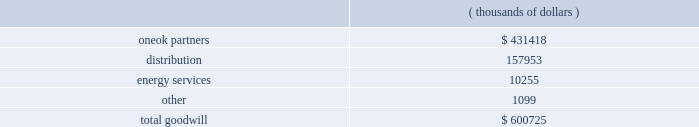Impairment of long-lived assets , goodwill and intangible assets - we assess our long-lived assets for impairment based on statement 144 , 201caccounting for the impairment or disposal of long-lived assets . 201d a long-lived asset is tested for impairment whenever events or changes in circumstances indicate that its carrying amount may exceed its fair value .
Fair values are based on the sum of the undiscounted future cash flows expected to result from the use and eventual disposition of the assets .
We assess our goodwill and intangible assets for impairment at least annually based on statement 142 , 201cgoodwill and other intangible assets . 201d there were no impairment charges resulting from the july 1 , 2007 , impairment tests and no events indicating an impairment have occurred subsequent to that date .
An initial assessment is made by comparing the fair value of the operations with goodwill , as determined in accordance with statement 142 , to the book value of each reporting unit .
If the fair value is less than the book value , an impairment is indicated , and we must perform a second test to measure the amount of the impairment .
In the second test , we calculate the implied fair value of the goodwill by deducting the fair value of all tangible and intangible net assets of the operations with goodwill from the fair value determined in step one of the assessment .
If the carrying value of the goodwill exceeds this calculated implied fair value of the goodwill , we will record an impairment charge .
At december 31 , 2007 , we had $ 600.7 million of goodwill recorded on our consolidated balance sheet as shown below. .
( thousands of dollars ) intangible assets with a finite useful life are amortized over their estimated useful life , while intangible assets with an indefinite useful life are not amortized .
All intangible assets are subject to impairment testing .
Our oneok partners segment had $ 443.0 million of intangible assets recorded on our consolidated balance sheet as of december 31 , 2007 , of which $ 287.5 million is being amortized over an aggregate weighted-average period of 40 years , while the remaining balance has an indefinite life .
During 2006 , we recorded a goodwill and asset impairment related to oneok partners 2019 black mesa pipeline of $ 8.4 million and $ 3.6 million , respectively , which were recorded as depreciation and amortization .
The reduction to our net income , net of minority interests and income taxes , was $ 3.0 million .
In the third quarter of 2005 , we made the decision to sell our spring creek power plant , located in oklahoma , and exit the power generation business .
In october 2005 , we concluded that our spring creek power plant had been impaired and recorded an impairment expense of $ 52.2 million .
This conclusion was based on our statement 144 impairment analysis of the results of operations for this plant through september 30 , 2005 , and also the net sales proceeds from the anticipated sale of the plant .
The sale was completed on october 31 , 2006 .
This component of our business is accounted for as discontinued operations in accordance with statement 144 .
See 201cdiscontinued operations 201d on page 46 for additional information .
Our total unamortized excess cost over underlying fair value of net assets accounted for under the equity method was $ 185.6 million as of december 31 , 2007 and 2006 .
Based on statement 142 , this amount , referred to as equity method goodwill , should continue to be recognized in accordance with apb opinion no .
18 , 201cthe equity method of accounting for investments in common stock . 201d accordingly , we included this amount in investment in unconsolidated affiliates on our accompanying consolidated balance sheets .
Pension and postretirement employee benefits - we have defined benefit retirement plans covering certain full-time employees .
We sponsor welfare plans that provide postretirement medical and life insurance benefits to certain employees who retire with at least five years of service .
Our actuarial consultant calculates the expense and liability related to these plans and uses statistical and other factors that attempt to anticipate future events .
These factors include assumptions about the discount rate , expected return on plan assets , rate of future compensation increases , age and employment periods .
In determining the projected benefit obligations and costs , assumptions can change from period to period and result in material changes in the costs and liabilities we recognize .
See note j of the notes to consolidated financial statements in this annual report on form 10-k for additional information. .
What percentage of total goodwill does oneok partners represent at december 31 , 2007? 
Computations: (431418 / 600725)
Answer: 0.71816. Impairment of long-lived assets , goodwill and intangible assets - we assess our long-lived assets for impairment based on statement 144 , 201caccounting for the impairment or disposal of long-lived assets . 201d a long-lived asset is tested for impairment whenever events or changes in circumstances indicate that its carrying amount may exceed its fair value .
Fair values are based on the sum of the undiscounted future cash flows expected to result from the use and eventual disposition of the assets .
We assess our goodwill and intangible assets for impairment at least annually based on statement 142 , 201cgoodwill and other intangible assets . 201d there were no impairment charges resulting from the july 1 , 2007 , impairment tests and no events indicating an impairment have occurred subsequent to that date .
An initial assessment is made by comparing the fair value of the operations with goodwill , as determined in accordance with statement 142 , to the book value of each reporting unit .
If the fair value is less than the book value , an impairment is indicated , and we must perform a second test to measure the amount of the impairment .
In the second test , we calculate the implied fair value of the goodwill by deducting the fair value of all tangible and intangible net assets of the operations with goodwill from the fair value determined in step one of the assessment .
If the carrying value of the goodwill exceeds this calculated implied fair value of the goodwill , we will record an impairment charge .
At december 31 , 2007 , we had $ 600.7 million of goodwill recorded on our consolidated balance sheet as shown below. .
( thousands of dollars ) intangible assets with a finite useful life are amortized over their estimated useful life , while intangible assets with an indefinite useful life are not amortized .
All intangible assets are subject to impairment testing .
Our oneok partners segment had $ 443.0 million of intangible assets recorded on our consolidated balance sheet as of december 31 , 2007 , of which $ 287.5 million is being amortized over an aggregate weighted-average period of 40 years , while the remaining balance has an indefinite life .
During 2006 , we recorded a goodwill and asset impairment related to oneok partners 2019 black mesa pipeline of $ 8.4 million and $ 3.6 million , respectively , which were recorded as depreciation and amortization .
The reduction to our net income , net of minority interests and income taxes , was $ 3.0 million .
In the third quarter of 2005 , we made the decision to sell our spring creek power plant , located in oklahoma , and exit the power generation business .
In october 2005 , we concluded that our spring creek power plant had been impaired and recorded an impairment expense of $ 52.2 million .
This conclusion was based on our statement 144 impairment analysis of the results of operations for this plant through september 30 , 2005 , and also the net sales proceeds from the anticipated sale of the plant .
The sale was completed on october 31 , 2006 .
This component of our business is accounted for as discontinued operations in accordance with statement 144 .
See 201cdiscontinued operations 201d on page 46 for additional information .
Our total unamortized excess cost over underlying fair value of net assets accounted for under the equity method was $ 185.6 million as of december 31 , 2007 and 2006 .
Based on statement 142 , this amount , referred to as equity method goodwill , should continue to be recognized in accordance with apb opinion no .
18 , 201cthe equity method of accounting for investments in common stock . 201d accordingly , we included this amount in investment in unconsolidated affiliates on our accompanying consolidated balance sheets .
Pension and postretirement employee benefits - we have defined benefit retirement plans covering certain full-time employees .
We sponsor welfare plans that provide postretirement medical and life insurance benefits to certain employees who retire with at least five years of service .
Our actuarial consultant calculates the expense and liability related to these plans and uses statistical and other factors that attempt to anticipate future events .
These factors include assumptions about the discount rate , expected return on plan assets , rate of future compensation increases , age and employment periods .
In determining the projected benefit obligations and costs , assumptions can change from period to period and result in material changes in the costs and liabilities we recognize .
See note j of the notes to consolidated financial statements in this annual report on form 10-k for additional information. .
What percentage of total goodwill does energy services represent at december 31 , 2007? 
Computations: (10255 / 600725)
Answer: 0.01707. 